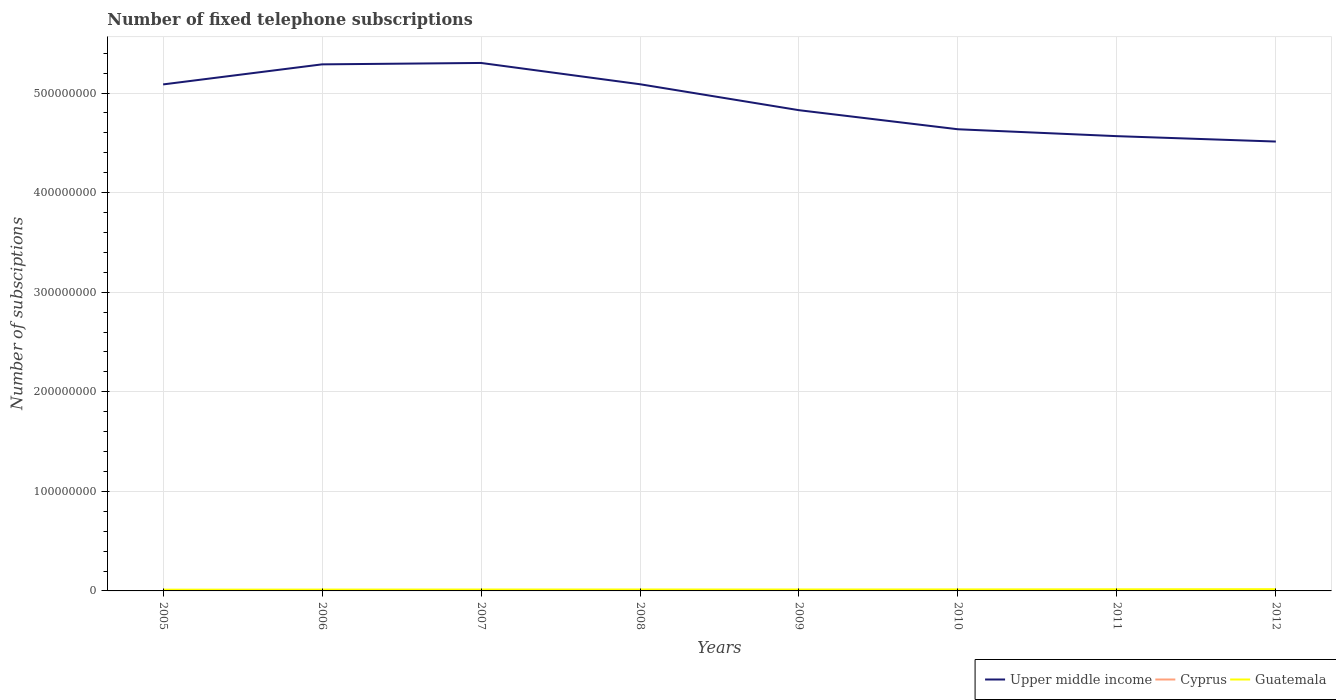Does the line corresponding to Upper middle income intersect with the line corresponding to Cyprus?
Provide a succinct answer. No. Is the number of lines equal to the number of legend labels?
Offer a very short reply. Yes. Across all years, what is the maximum number of fixed telephone subscriptions in Upper middle income?
Offer a terse response. 4.51e+08. What is the total number of fixed telephone subscriptions in Upper middle income in the graph?
Your response must be concise. 1.92e+07. What is the difference between the highest and the second highest number of fixed telephone subscriptions in Upper middle income?
Offer a very short reply. 7.89e+07. What is the difference between the highest and the lowest number of fixed telephone subscriptions in Upper middle income?
Provide a short and direct response. 4. How many lines are there?
Your answer should be very brief. 3. What is the difference between two consecutive major ticks on the Y-axis?
Your response must be concise. 1.00e+08. Are the values on the major ticks of Y-axis written in scientific E-notation?
Provide a succinct answer. No. Does the graph contain grids?
Offer a very short reply. Yes. What is the title of the graph?
Offer a very short reply. Number of fixed telephone subscriptions. Does "Cabo Verde" appear as one of the legend labels in the graph?
Ensure brevity in your answer.  No. What is the label or title of the X-axis?
Your response must be concise. Years. What is the label or title of the Y-axis?
Provide a short and direct response. Number of subsciptions. What is the Number of subsciptions in Upper middle income in 2005?
Ensure brevity in your answer.  5.09e+08. What is the Number of subsciptions of Cyprus in 2005?
Offer a very short reply. 4.20e+05. What is the Number of subsciptions in Guatemala in 2005?
Your answer should be very brief. 1.25e+06. What is the Number of subsciptions in Upper middle income in 2006?
Your response must be concise. 5.29e+08. What is the Number of subsciptions of Cyprus in 2006?
Keep it short and to the point. 4.08e+05. What is the Number of subsciptions of Guatemala in 2006?
Keep it short and to the point. 1.35e+06. What is the Number of subsciptions of Upper middle income in 2007?
Your answer should be compact. 5.30e+08. What is the Number of subsciptions of Cyprus in 2007?
Your answer should be compact. 4.09e+05. What is the Number of subsciptions in Guatemala in 2007?
Your answer should be very brief. 1.41e+06. What is the Number of subsciptions of Upper middle income in 2008?
Your answer should be very brief. 5.09e+08. What is the Number of subsciptions in Cyprus in 2008?
Make the answer very short. 4.13e+05. What is the Number of subsciptions in Guatemala in 2008?
Give a very brief answer. 1.45e+06. What is the Number of subsciptions in Upper middle income in 2009?
Make the answer very short. 4.83e+08. What is the Number of subsciptions of Cyprus in 2009?
Your response must be concise. 4.15e+05. What is the Number of subsciptions of Guatemala in 2009?
Your response must be concise. 1.41e+06. What is the Number of subsciptions in Upper middle income in 2010?
Your answer should be very brief. 4.64e+08. What is the Number of subsciptions of Cyprus in 2010?
Your answer should be very brief. 4.13e+05. What is the Number of subsciptions of Guatemala in 2010?
Make the answer very short. 1.50e+06. What is the Number of subsciptions of Upper middle income in 2011?
Offer a terse response. 4.57e+08. What is the Number of subsciptions in Cyprus in 2011?
Offer a very short reply. 4.05e+05. What is the Number of subsciptions in Guatemala in 2011?
Ensure brevity in your answer.  1.63e+06. What is the Number of subsciptions of Upper middle income in 2012?
Offer a terse response. 4.51e+08. What is the Number of subsciptions in Cyprus in 2012?
Keep it short and to the point. 3.73e+05. What is the Number of subsciptions of Guatemala in 2012?
Your answer should be compact. 1.74e+06. Across all years, what is the maximum Number of subsciptions of Upper middle income?
Provide a short and direct response. 5.30e+08. Across all years, what is the maximum Number of subsciptions of Cyprus?
Offer a very short reply. 4.20e+05. Across all years, what is the maximum Number of subsciptions of Guatemala?
Provide a short and direct response. 1.74e+06. Across all years, what is the minimum Number of subsciptions of Upper middle income?
Keep it short and to the point. 4.51e+08. Across all years, what is the minimum Number of subsciptions in Cyprus?
Offer a very short reply. 3.73e+05. Across all years, what is the minimum Number of subsciptions of Guatemala?
Keep it short and to the point. 1.25e+06. What is the total Number of subsciptions in Upper middle income in the graph?
Your answer should be compact. 3.93e+09. What is the total Number of subsciptions in Cyprus in the graph?
Make the answer very short. 3.26e+06. What is the total Number of subsciptions of Guatemala in the graph?
Offer a very short reply. 1.17e+07. What is the difference between the Number of subsciptions in Upper middle income in 2005 and that in 2006?
Offer a terse response. -2.01e+07. What is the difference between the Number of subsciptions of Cyprus in 2005 and that in 2006?
Give a very brief answer. 1.17e+04. What is the difference between the Number of subsciptions in Guatemala in 2005 and that in 2006?
Your response must be concise. -1.07e+05. What is the difference between the Number of subsciptions in Upper middle income in 2005 and that in 2007?
Keep it short and to the point. -2.15e+07. What is the difference between the Number of subsciptions in Cyprus in 2005 and that in 2007?
Offer a terse response. 1.08e+04. What is the difference between the Number of subsciptions in Guatemala in 2005 and that in 2007?
Your answer should be very brief. -1.66e+05. What is the difference between the Number of subsciptions in Upper middle income in 2005 and that in 2008?
Provide a short and direct response. -1.67e+05. What is the difference between the Number of subsciptions in Cyprus in 2005 and that in 2008?
Your answer should be compact. 6707. What is the difference between the Number of subsciptions in Guatemala in 2005 and that in 2008?
Your answer should be compact. -2.01e+05. What is the difference between the Number of subsciptions of Upper middle income in 2005 and that in 2009?
Keep it short and to the point. 2.59e+07. What is the difference between the Number of subsciptions in Cyprus in 2005 and that in 2009?
Your response must be concise. 5518. What is the difference between the Number of subsciptions in Guatemala in 2005 and that in 2009?
Your answer should be compact. -1.65e+05. What is the difference between the Number of subsciptions of Upper middle income in 2005 and that in 2010?
Ensure brevity in your answer.  4.50e+07. What is the difference between the Number of subsciptions of Cyprus in 2005 and that in 2010?
Your answer should be very brief. 6838. What is the difference between the Number of subsciptions in Guatemala in 2005 and that in 2010?
Make the answer very short. -2.50e+05. What is the difference between the Number of subsciptions in Upper middle income in 2005 and that in 2011?
Your answer should be compact. 5.20e+07. What is the difference between the Number of subsciptions of Cyprus in 2005 and that in 2011?
Make the answer very short. 1.50e+04. What is the difference between the Number of subsciptions of Guatemala in 2005 and that in 2011?
Make the answer very short. -3.78e+05. What is the difference between the Number of subsciptions of Upper middle income in 2005 and that in 2012?
Provide a succinct answer. 5.74e+07. What is the difference between the Number of subsciptions in Cyprus in 2005 and that in 2012?
Provide a short and direct response. 4.68e+04. What is the difference between the Number of subsciptions in Guatemala in 2005 and that in 2012?
Your response must be concise. -4.96e+05. What is the difference between the Number of subsciptions in Upper middle income in 2006 and that in 2007?
Provide a short and direct response. -1.41e+06. What is the difference between the Number of subsciptions of Cyprus in 2006 and that in 2007?
Provide a succinct answer. -960. What is the difference between the Number of subsciptions in Guatemala in 2006 and that in 2007?
Provide a succinct answer. -5.88e+04. What is the difference between the Number of subsciptions of Upper middle income in 2006 and that in 2008?
Offer a terse response. 2.00e+07. What is the difference between the Number of subsciptions in Cyprus in 2006 and that in 2008?
Provide a short and direct response. -5004. What is the difference between the Number of subsciptions in Guatemala in 2006 and that in 2008?
Your answer should be compact. -9.40e+04. What is the difference between the Number of subsciptions in Upper middle income in 2006 and that in 2009?
Offer a terse response. 4.60e+07. What is the difference between the Number of subsciptions of Cyprus in 2006 and that in 2009?
Ensure brevity in your answer.  -6193. What is the difference between the Number of subsciptions in Guatemala in 2006 and that in 2009?
Offer a terse response. -5.83e+04. What is the difference between the Number of subsciptions of Upper middle income in 2006 and that in 2010?
Your answer should be very brief. 6.52e+07. What is the difference between the Number of subsciptions in Cyprus in 2006 and that in 2010?
Give a very brief answer. -4873. What is the difference between the Number of subsciptions in Guatemala in 2006 and that in 2010?
Provide a succinct answer. -1.44e+05. What is the difference between the Number of subsciptions in Upper middle income in 2006 and that in 2011?
Provide a succinct answer. 7.21e+07. What is the difference between the Number of subsciptions in Cyprus in 2006 and that in 2011?
Ensure brevity in your answer.  3295. What is the difference between the Number of subsciptions in Guatemala in 2006 and that in 2011?
Provide a short and direct response. -2.71e+05. What is the difference between the Number of subsciptions in Upper middle income in 2006 and that in 2012?
Make the answer very short. 7.75e+07. What is the difference between the Number of subsciptions of Cyprus in 2006 and that in 2012?
Your answer should be very brief. 3.51e+04. What is the difference between the Number of subsciptions in Guatemala in 2006 and that in 2012?
Your answer should be compact. -3.89e+05. What is the difference between the Number of subsciptions of Upper middle income in 2007 and that in 2008?
Your answer should be compact. 2.14e+07. What is the difference between the Number of subsciptions in Cyprus in 2007 and that in 2008?
Give a very brief answer. -4044. What is the difference between the Number of subsciptions in Guatemala in 2007 and that in 2008?
Keep it short and to the point. -3.52e+04. What is the difference between the Number of subsciptions in Upper middle income in 2007 and that in 2009?
Provide a succinct answer. 4.74e+07. What is the difference between the Number of subsciptions in Cyprus in 2007 and that in 2009?
Offer a very short reply. -5233. What is the difference between the Number of subsciptions of Guatemala in 2007 and that in 2009?
Your answer should be very brief. 461. What is the difference between the Number of subsciptions of Upper middle income in 2007 and that in 2010?
Give a very brief answer. 6.66e+07. What is the difference between the Number of subsciptions in Cyprus in 2007 and that in 2010?
Your response must be concise. -3913. What is the difference between the Number of subsciptions in Guatemala in 2007 and that in 2010?
Provide a succinct answer. -8.49e+04. What is the difference between the Number of subsciptions of Upper middle income in 2007 and that in 2011?
Offer a very short reply. 7.35e+07. What is the difference between the Number of subsciptions of Cyprus in 2007 and that in 2011?
Your answer should be very brief. 4255. What is the difference between the Number of subsciptions of Guatemala in 2007 and that in 2011?
Make the answer very short. -2.13e+05. What is the difference between the Number of subsciptions in Upper middle income in 2007 and that in 2012?
Offer a very short reply. 7.89e+07. What is the difference between the Number of subsciptions in Cyprus in 2007 and that in 2012?
Offer a very short reply. 3.61e+04. What is the difference between the Number of subsciptions in Guatemala in 2007 and that in 2012?
Provide a short and direct response. -3.30e+05. What is the difference between the Number of subsciptions of Upper middle income in 2008 and that in 2009?
Provide a short and direct response. 2.61e+07. What is the difference between the Number of subsciptions in Cyprus in 2008 and that in 2009?
Your answer should be compact. -1189. What is the difference between the Number of subsciptions in Guatemala in 2008 and that in 2009?
Provide a succinct answer. 3.57e+04. What is the difference between the Number of subsciptions in Upper middle income in 2008 and that in 2010?
Your response must be concise. 4.52e+07. What is the difference between the Number of subsciptions of Cyprus in 2008 and that in 2010?
Provide a short and direct response. 131. What is the difference between the Number of subsciptions in Guatemala in 2008 and that in 2010?
Provide a short and direct response. -4.97e+04. What is the difference between the Number of subsciptions of Upper middle income in 2008 and that in 2011?
Ensure brevity in your answer.  5.21e+07. What is the difference between the Number of subsciptions in Cyprus in 2008 and that in 2011?
Give a very brief answer. 8299. What is the difference between the Number of subsciptions in Guatemala in 2008 and that in 2011?
Your answer should be compact. -1.77e+05. What is the difference between the Number of subsciptions of Upper middle income in 2008 and that in 2012?
Your answer should be compact. 5.75e+07. What is the difference between the Number of subsciptions in Cyprus in 2008 and that in 2012?
Offer a very short reply. 4.01e+04. What is the difference between the Number of subsciptions of Guatemala in 2008 and that in 2012?
Provide a short and direct response. -2.95e+05. What is the difference between the Number of subsciptions of Upper middle income in 2009 and that in 2010?
Your response must be concise. 1.92e+07. What is the difference between the Number of subsciptions in Cyprus in 2009 and that in 2010?
Your answer should be very brief. 1320. What is the difference between the Number of subsciptions of Guatemala in 2009 and that in 2010?
Make the answer very short. -8.54e+04. What is the difference between the Number of subsciptions in Upper middle income in 2009 and that in 2011?
Keep it short and to the point. 2.61e+07. What is the difference between the Number of subsciptions of Cyprus in 2009 and that in 2011?
Offer a very short reply. 9488. What is the difference between the Number of subsciptions in Guatemala in 2009 and that in 2011?
Provide a succinct answer. -2.13e+05. What is the difference between the Number of subsciptions of Upper middle income in 2009 and that in 2012?
Keep it short and to the point. 3.15e+07. What is the difference between the Number of subsciptions of Cyprus in 2009 and that in 2012?
Your response must be concise. 4.13e+04. What is the difference between the Number of subsciptions in Guatemala in 2009 and that in 2012?
Offer a very short reply. -3.31e+05. What is the difference between the Number of subsciptions of Upper middle income in 2010 and that in 2011?
Provide a short and direct response. 6.92e+06. What is the difference between the Number of subsciptions of Cyprus in 2010 and that in 2011?
Your response must be concise. 8168. What is the difference between the Number of subsciptions in Guatemala in 2010 and that in 2011?
Keep it short and to the point. -1.28e+05. What is the difference between the Number of subsciptions in Upper middle income in 2010 and that in 2012?
Your answer should be compact. 1.23e+07. What is the difference between the Number of subsciptions of Cyprus in 2010 and that in 2012?
Offer a very short reply. 4.00e+04. What is the difference between the Number of subsciptions of Guatemala in 2010 and that in 2012?
Provide a short and direct response. -2.45e+05. What is the difference between the Number of subsciptions in Upper middle income in 2011 and that in 2012?
Offer a terse response. 5.41e+06. What is the difference between the Number of subsciptions of Cyprus in 2011 and that in 2012?
Your response must be concise. 3.18e+04. What is the difference between the Number of subsciptions of Guatemala in 2011 and that in 2012?
Your response must be concise. -1.18e+05. What is the difference between the Number of subsciptions in Upper middle income in 2005 and the Number of subsciptions in Cyprus in 2006?
Your answer should be very brief. 5.08e+08. What is the difference between the Number of subsciptions in Upper middle income in 2005 and the Number of subsciptions in Guatemala in 2006?
Your answer should be very brief. 5.07e+08. What is the difference between the Number of subsciptions in Cyprus in 2005 and the Number of subsciptions in Guatemala in 2006?
Your answer should be very brief. -9.35e+05. What is the difference between the Number of subsciptions of Upper middle income in 2005 and the Number of subsciptions of Cyprus in 2007?
Keep it short and to the point. 5.08e+08. What is the difference between the Number of subsciptions in Upper middle income in 2005 and the Number of subsciptions in Guatemala in 2007?
Your response must be concise. 5.07e+08. What is the difference between the Number of subsciptions of Cyprus in 2005 and the Number of subsciptions of Guatemala in 2007?
Provide a short and direct response. -9.94e+05. What is the difference between the Number of subsciptions of Upper middle income in 2005 and the Number of subsciptions of Cyprus in 2008?
Your answer should be very brief. 5.08e+08. What is the difference between the Number of subsciptions of Upper middle income in 2005 and the Number of subsciptions of Guatemala in 2008?
Your answer should be very brief. 5.07e+08. What is the difference between the Number of subsciptions of Cyprus in 2005 and the Number of subsciptions of Guatemala in 2008?
Ensure brevity in your answer.  -1.03e+06. What is the difference between the Number of subsciptions of Upper middle income in 2005 and the Number of subsciptions of Cyprus in 2009?
Provide a short and direct response. 5.08e+08. What is the difference between the Number of subsciptions in Upper middle income in 2005 and the Number of subsciptions in Guatemala in 2009?
Your answer should be very brief. 5.07e+08. What is the difference between the Number of subsciptions in Cyprus in 2005 and the Number of subsciptions in Guatemala in 2009?
Provide a succinct answer. -9.93e+05. What is the difference between the Number of subsciptions of Upper middle income in 2005 and the Number of subsciptions of Cyprus in 2010?
Your answer should be compact. 5.08e+08. What is the difference between the Number of subsciptions in Upper middle income in 2005 and the Number of subsciptions in Guatemala in 2010?
Give a very brief answer. 5.07e+08. What is the difference between the Number of subsciptions of Cyprus in 2005 and the Number of subsciptions of Guatemala in 2010?
Ensure brevity in your answer.  -1.08e+06. What is the difference between the Number of subsciptions in Upper middle income in 2005 and the Number of subsciptions in Cyprus in 2011?
Provide a succinct answer. 5.08e+08. What is the difference between the Number of subsciptions of Upper middle income in 2005 and the Number of subsciptions of Guatemala in 2011?
Offer a terse response. 5.07e+08. What is the difference between the Number of subsciptions in Cyprus in 2005 and the Number of subsciptions in Guatemala in 2011?
Your response must be concise. -1.21e+06. What is the difference between the Number of subsciptions in Upper middle income in 2005 and the Number of subsciptions in Cyprus in 2012?
Make the answer very short. 5.08e+08. What is the difference between the Number of subsciptions in Upper middle income in 2005 and the Number of subsciptions in Guatemala in 2012?
Your answer should be very brief. 5.07e+08. What is the difference between the Number of subsciptions in Cyprus in 2005 and the Number of subsciptions in Guatemala in 2012?
Your answer should be compact. -1.32e+06. What is the difference between the Number of subsciptions in Upper middle income in 2006 and the Number of subsciptions in Cyprus in 2007?
Make the answer very short. 5.28e+08. What is the difference between the Number of subsciptions in Upper middle income in 2006 and the Number of subsciptions in Guatemala in 2007?
Offer a terse response. 5.27e+08. What is the difference between the Number of subsciptions in Cyprus in 2006 and the Number of subsciptions in Guatemala in 2007?
Provide a succinct answer. -1.01e+06. What is the difference between the Number of subsciptions of Upper middle income in 2006 and the Number of subsciptions of Cyprus in 2008?
Keep it short and to the point. 5.28e+08. What is the difference between the Number of subsciptions in Upper middle income in 2006 and the Number of subsciptions in Guatemala in 2008?
Your answer should be very brief. 5.27e+08. What is the difference between the Number of subsciptions of Cyprus in 2006 and the Number of subsciptions of Guatemala in 2008?
Offer a very short reply. -1.04e+06. What is the difference between the Number of subsciptions in Upper middle income in 2006 and the Number of subsciptions in Cyprus in 2009?
Offer a terse response. 5.28e+08. What is the difference between the Number of subsciptions in Upper middle income in 2006 and the Number of subsciptions in Guatemala in 2009?
Ensure brevity in your answer.  5.27e+08. What is the difference between the Number of subsciptions in Cyprus in 2006 and the Number of subsciptions in Guatemala in 2009?
Your answer should be very brief. -1.00e+06. What is the difference between the Number of subsciptions of Upper middle income in 2006 and the Number of subsciptions of Cyprus in 2010?
Provide a short and direct response. 5.28e+08. What is the difference between the Number of subsciptions of Upper middle income in 2006 and the Number of subsciptions of Guatemala in 2010?
Make the answer very short. 5.27e+08. What is the difference between the Number of subsciptions of Cyprus in 2006 and the Number of subsciptions of Guatemala in 2010?
Your answer should be compact. -1.09e+06. What is the difference between the Number of subsciptions of Upper middle income in 2006 and the Number of subsciptions of Cyprus in 2011?
Make the answer very short. 5.28e+08. What is the difference between the Number of subsciptions in Upper middle income in 2006 and the Number of subsciptions in Guatemala in 2011?
Give a very brief answer. 5.27e+08. What is the difference between the Number of subsciptions of Cyprus in 2006 and the Number of subsciptions of Guatemala in 2011?
Make the answer very short. -1.22e+06. What is the difference between the Number of subsciptions in Upper middle income in 2006 and the Number of subsciptions in Cyprus in 2012?
Your answer should be compact. 5.28e+08. What is the difference between the Number of subsciptions of Upper middle income in 2006 and the Number of subsciptions of Guatemala in 2012?
Offer a terse response. 5.27e+08. What is the difference between the Number of subsciptions in Cyprus in 2006 and the Number of subsciptions in Guatemala in 2012?
Your response must be concise. -1.34e+06. What is the difference between the Number of subsciptions of Upper middle income in 2007 and the Number of subsciptions of Cyprus in 2008?
Your answer should be compact. 5.30e+08. What is the difference between the Number of subsciptions of Upper middle income in 2007 and the Number of subsciptions of Guatemala in 2008?
Provide a short and direct response. 5.29e+08. What is the difference between the Number of subsciptions in Cyprus in 2007 and the Number of subsciptions in Guatemala in 2008?
Your answer should be very brief. -1.04e+06. What is the difference between the Number of subsciptions of Upper middle income in 2007 and the Number of subsciptions of Cyprus in 2009?
Your answer should be compact. 5.30e+08. What is the difference between the Number of subsciptions in Upper middle income in 2007 and the Number of subsciptions in Guatemala in 2009?
Provide a succinct answer. 5.29e+08. What is the difference between the Number of subsciptions in Cyprus in 2007 and the Number of subsciptions in Guatemala in 2009?
Your response must be concise. -1.00e+06. What is the difference between the Number of subsciptions of Upper middle income in 2007 and the Number of subsciptions of Cyprus in 2010?
Give a very brief answer. 5.30e+08. What is the difference between the Number of subsciptions in Upper middle income in 2007 and the Number of subsciptions in Guatemala in 2010?
Provide a succinct answer. 5.29e+08. What is the difference between the Number of subsciptions of Cyprus in 2007 and the Number of subsciptions of Guatemala in 2010?
Offer a very short reply. -1.09e+06. What is the difference between the Number of subsciptions of Upper middle income in 2007 and the Number of subsciptions of Cyprus in 2011?
Provide a short and direct response. 5.30e+08. What is the difference between the Number of subsciptions in Upper middle income in 2007 and the Number of subsciptions in Guatemala in 2011?
Your answer should be compact. 5.29e+08. What is the difference between the Number of subsciptions in Cyprus in 2007 and the Number of subsciptions in Guatemala in 2011?
Keep it short and to the point. -1.22e+06. What is the difference between the Number of subsciptions of Upper middle income in 2007 and the Number of subsciptions of Cyprus in 2012?
Your answer should be compact. 5.30e+08. What is the difference between the Number of subsciptions of Upper middle income in 2007 and the Number of subsciptions of Guatemala in 2012?
Your answer should be compact. 5.28e+08. What is the difference between the Number of subsciptions of Cyprus in 2007 and the Number of subsciptions of Guatemala in 2012?
Ensure brevity in your answer.  -1.33e+06. What is the difference between the Number of subsciptions in Upper middle income in 2008 and the Number of subsciptions in Cyprus in 2009?
Keep it short and to the point. 5.08e+08. What is the difference between the Number of subsciptions of Upper middle income in 2008 and the Number of subsciptions of Guatemala in 2009?
Your answer should be very brief. 5.07e+08. What is the difference between the Number of subsciptions of Cyprus in 2008 and the Number of subsciptions of Guatemala in 2009?
Keep it short and to the point. -1.00e+06. What is the difference between the Number of subsciptions in Upper middle income in 2008 and the Number of subsciptions in Cyprus in 2010?
Ensure brevity in your answer.  5.08e+08. What is the difference between the Number of subsciptions in Upper middle income in 2008 and the Number of subsciptions in Guatemala in 2010?
Your answer should be compact. 5.07e+08. What is the difference between the Number of subsciptions in Cyprus in 2008 and the Number of subsciptions in Guatemala in 2010?
Keep it short and to the point. -1.09e+06. What is the difference between the Number of subsciptions in Upper middle income in 2008 and the Number of subsciptions in Cyprus in 2011?
Provide a short and direct response. 5.08e+08. What is the difference between the Number of subsciptions in Upper middle income in 2008 and the Number of subsciptions in Guatemala in 2011?
Offer a terse response. 5.07e+08. What is the difference between the Number of subsciptions of Cyprus in 2008 and the Number of subsciptions of Guatemala in 2011?
Keep it short and to the point. -1.21e+06. What is the difference between the Number of subsciptions of Upper middle income in 2008 and the Number of subsciptions of Cyprus in 2012?
Provide a short and direct response. 5.08e+08. What is the difference between the Number of subsciptions in Upper middle income in 2008 and the Number of subsciptions in Guatemala in 2012?
Keep it short and to the point. 5.07e+08. What is the difference between the Number of subsciptions of Cyprus in 2008 and the Number of subsciptions of Guatemala in 2012?
Offer a very short reply. -1.33e+06. What is the difference between the Number of subsciptions of Upper middle income in 2009 and the Number of subsciptions of Cyprus in 2010?
Provide a succinct answer. 4.82e+08. What is the difference between the Number of subsciptions of Upper middle income in 2009 and the Number of subsciptions of Guatemala in 2010?
Provide a short and direct response. 4.81e+08. What is the difference between the Number of subsciptions in Cyprus in 2009 and the Number of subsciptions in Guatemala in 2010?
Your answer should be compact. -1.08e+06. What is the difference between the Number of subsciptions of Upper middle income in 2009 and the Number of subsciptions of Cyprus in 2011?
Provide a short and direct response. 4.82e+08. What is the difference between the Number of subsciptions of Upper middle income in 2009 and the Number of subsciptions of Guatemala in 2011?
Keep it short and to the point. 4.81e+08. What is the difference between the Number of subsciptions in Cyprus in 2009 and the Number of subsciptions in Guatemala in 2011?
Make the answer very short. -1.21e+06. What is the difference between the Number of subsciptions in Upper middle income in 2009 and the Number of subsciptions in Cyprus in 2012?
Keep it short and to the point. 4.82e+08. What is the difference between the Number of subsciptions in Upper middle income in 2009 and the Number of subsciptions in Guatemala in 2012?
Your answer should be compact. 4.81e+08. What is the difference between the Number of subsciptions in Cyprus in 2009 and the Number of subsciptions in Guatemala in 2012?
Your response must be concise. -1.33e+06. What is the difference between the Number of subsciptions of Upper middle income in 2010 and the Number of subsciptions of Cyprus in 2011?
Your answer should be compact. 4.63e+08. What is the difference between the Number of subsciptions in Upper middle income in 2010 and the Number of subsciptions in Guatemala in 2011?
Your answer should be very brief. 4.62e+08. What is the difference between the Number of subsciptions in Cyprus in 2010 and the Number of subsciptions in Guatemala in 2011?
Keep it short and to the point. -1.21e+06. What is the difference between the Number of subsciptions in Upper middle income in 2010 and the Number of subsciptions in Cyprus in 2012?
Offer a very short reply. 4.63e+08. What is the difference between the Number of subsciptions of Upper middle income in 2010 and the Number of subsciptions of Guatemala in 2012?
Your answer should be compact. 4.62e+08. What is the difference between the Number of subsciptions in Cyprus in 2010 and the Number of subsciptions in Guatemala in 2012?
Offer a very short reply. -1.33e+06. What is the difference between the Number of subsciptions in Upper middle income in 2011 and the Number of subsciptions in Cyprus in 2012?
Provide a short and direct response. 4.56e+08. What is the difference between the Number of subsciptions of Upper middle income in 2011 and the Number of subsciptions of Guatemala in 2012?
Your answer should be very brief. 4.55e+08. What is the difference between the Number of subsciptions of Cyprus in 2011 and the Number of subsciptions of Guatemala in 2012?
Offer a very short reply. -1.34e+06. What is the average Number of subsciptions of Upper middle income per year?
Offer a very short reply. 4.91e+08. What is the average Number of subsciptions of Cyprus per year?
Your answer should be very brief. 4.07e+05. What is the average Number of subsciptions of Guatemala per year?
Provide a succinct answer. 1.47e+06. In the year 2005, what is the difference between the Number of subsciptions of Upper middle income and Number of subsciptions of Cyprus?
Provide a succinct answer. 5.08e+08. In the year 2005, what is the difference between the Number of subsciptions in Upper middle income and Number of subsciptions in Guatemala?
Your answer should be very brief. 5.07e+08. In the year 2005, what is the difference between the Number of subsciptions of Cyprus and Number of subsciptions of Guatemala?
Offer a very short reply. -8.28e+05. In the year 2006, what is the difference between the Number of subsciptions in Upper middle income and Number of subsciptions in Cyprus?
Keep it short and to the point. 5.28e+08. In the year 2006, what is the difference between the Number of subsciptions in Upper middle income and Number of subsciptions in Guatemala?
Your answer should be compact. 5.27e+08. In the year 2006, what is the difference between the Number of subsciptions in Cyprus and Number of subsciptions in Guatemala?
Offer a terse response. -9.47e+05. In the year 2007, what is the difference between the Number of subsciptions in Upper middle income and Number of subsciptions in Cyprus?
Offer a terse response. 5.30e+08. In the year 2007, what is the difference between the Number of subsciptions in Upper middle income and Number of subsciptions in Guatemala?
Offer a terse response. 5.29e+08. In the year 2007, what is the difference between the Number of subsciptions of Cyprus and Number of subsciptions of Guatemala?
Your response must be concise. -1.00e+06. In the year 2008, what is the difference between the Number of subsciptions in Upper middle income and Number of subsciptions in Cyprus?
Ensure brevity in your answer.  5.08e+08. In the year 2008, what is the difference between the Number of subsciptions of Upper middle income and Number of subsciptions of Guatemala?
Keep it short and to the point. 5.07e+08. In the year 2008, what is the difference between the Number of subsciptions of Cyprus and Number of subsciptions of Guatemala?
Give a very brief answer. -1.04e+06. In the year 2009, what is the difference between the Number of subsciptions in Upper middle income and Number of subsciptions in Cyprus?
Provide a short and direct response. 4.82e+08. In the year 2009, what is the difference between the Number of subsciptions of Upper middle income and Number of subsciptions of Guatemala?
Offer a terse response. 4.81e+08. In the year 2009, what is the difference between the Number of subsciptions of Cyprus and Number of subsciptions of Guatemala?
Your response must be concise. -9.99e+05. In the year 2010, what is the difference between the Number of subsciptions of Upper middle income and Number of subsciptions of Cyprus?
Keep it short and to the point. 4.63e+08. In the year 2010, what is the difference between the Number of subsciptions in Upper middle income and Number of subsciptions in Guatemala?
Your answer should be compact. 4.62e+08. In the year 2010, what is the difference between the Number of subsciptions of Cyprus and Number of subsciptions of Guatemala?
Keep it short and to the point. -1.09e+06. In the year 2011, what is the difference between the Number of subsciptions in Upper middle income and Number of subsciptions in Cyprus?
Keep it short and to the point. 4.56e+08. In the year 2011, what is the difference between the Number of subsciptions of Upper middle income and Number of subsciptions of Guatemala?
Your response must be concise. 4.55e+08. In the year 2011, what is the difference between the Number of subsciptions of Cyprus and Number of subsciptions of Guatemala?
Ensure brevity in your answer.  -1.22e+06. In the year 2012, what is the difference between the Number of subsciptions of Upper middle income and Number of subsciptions of Cyprus?
Keep it short and to the point. 4.51e+08. In the year 2012, what is the difference between the Number of subsciptions of Upper middle income and Number of subsciptions of Guatemala?
Keep it short and to the point. 4.50e+08. In the year 2012, what is the difference between the Number of subsciptions in Cyprus and Number of subsciptions in Guatemala?
Your response must be concise. -1.37e+06. What is the ratio of the Number of subsciptions of Upper middle income in 2005 to that in 2006?
Offer a terse response. 0.96. What is the ratio of the Number of subsciptions in Cyprus in 2005 to that in 2006?
Provide a short and direct response. 1.03. What is the ratio of the Number of subsciptions in Guatemala in 2005 to that in 2006?
Your answer should be very brief. 0.92. What is the ratio of the Number of subsciptions of Upper middle income in 2005 to that in 2007?
Your answer should be very brief. 0.96. What is the ratio of the Number of subsciptions in Cyprus in 2005 to that in 2007?
Offer a very short reply. 1.03. What is the ratio of the Number of subsciptions in Guatemala in 2005 to that in 2007?
Offer a very short reply. 0.88. What is the ratio of the Number of subsciptions of Upper middle income in 2005 to that in 2008?
Provide a succinct answer. 1. What is the ratio of the Number of subsciptions in Cyprus in 2005 to that in 2008?
Offer a terse response. 1.02. What is the ratio of the Number of subsciptions of Guatemala in 2005 to that in 2008?
Your answer should be very brief. 0.86. What is the ratio of the Number of subsciptions of Upper middle income in 2005 to that in 2009?
Your response must be concise. 1.05. What is the ratio of the Number of subsciptions in Cyprus in 2005 to that in 2009?
Your answer should be very brief. 1.01. What is the ratio of the Number of subsciptions of Guatemala in 2005 to that in 2009?
Offer a very short reply. 0.88. What is the ratio of the Number of subsciptions of Upper middle income in 2005 to that in 2010?
Provide a short and direct response. 1.1. What is the ratio of the Number of subsciptions of Cyprus in 2005 to that in 2010?
Keep it short and to the point. 1.02. What is the ratio of the Number of subsciptions of Guatemala in 2005 to that in 2010?
Your response must be concise. 0.83. What is the ratio of the Number of subsciptions of Upper middle income in 2005 to that in 2011?
Your answer should be compact. 1.11. What is the ratio of the Number of subsciptions in Guatemala in 2005 to that in 2011?
Your response must be concise. 0.77. What is the ratio of the Number of subsciptions in Upper middle income in 2005 to that in 2012?
Make the answer very short. 1.13. What is the ratio of the Number of subsciptions in Cyprus in 2005 to that in 2012?
Offer a terse response. 1.13. What is the ratio of the Number of subsciptions in Guatemala in 2005 to that in 2012?
Offer a terse response. 0.72. What is the ratio of the Number of subsciptions in Upper middle income in 2006 to that in 2007?
Provide a short and direct response. 1. What is the ratio of the Number of subsciptions of Guatemala in 2006 to that in 2007?
Keep it short and to the point. 0.96. What is the ratio of the Number of subsciptions of Upper middle income in 2006 to that in 2008?
Give a very brief answer. 1.04. What is the ratio of the Number of subsciptions of Cyprus in 2006 to that in 2008?
Your response must be concise. 0.99. What is the ratio of the Number of subsciptions of Guatemala in 2006 to that in 2008?
Provide a short and direct response. 0.94. What is the ratio of the Number of subsciptions of Upper middle income in 2006 to that in 2009?
Your answer should be compact. 1.1. What is the ratio of the Number of subsciptions of Cyprus in 2006 to that in 2009?
Your answer should be very brief. 0.99. What is the ratio of the Number of subsciptions in Guatemala in 2006 to that in 2009?
Give a very brief answer. 0.96. What is the ratio of the Number of subsciptions in Upper middle income in 2006 to that in 2010?
Your answer should be compact. 1.14. What is the ratio of the Number of subsciptions of Guatemala in 2006 to that in 2010?
Your answer should be compact. 0.9. What is the ratio of the Number of subsciptions in Upper middle income in 2006 to that in 2011?
Your answer should be compact. 1.16. What is the ratio of the Number of subsciptions of Cyprus in 2006 to that in 2011?
Ensure brevity in your answer.  1.01. What is the ratio of the Number of subsciptions of Guatemala in 2006 to that in 2011?
Your answer should be compact. 0.83. What is the ratio of the Number of subsciptions in Upper middle income in 2006 to that in 2012?
Your response must be concise. 1.17. What is the ratio of the Number of subsciptions in Cyprus in 2006 to that in 2012?
Your answer should be compact. 1.09. What is the ratio of the Number of subsciptions of Guatemala in 2006 to that in 2012?
Provide a short and direct response. 0.78. What is the ratio of the Number of subsciptions in Upper middle income in 2007 to that in 2008?
Offer a terse response. 1.04. What is the ratio of the Number of subsciptions of Cyprus in 2007 to that in 2008?
Offer a very short reply. 0.99. What is the ratio of the Number of subsciptions of Guatemala in 2007 to that in 2008?
Ensure brevity in your answer.  0.98. What is the ratio of the Number of subsciptions in Upper middle income in 2007 to that in 2009?
Your response must be concise. 1.1. What is the ratio of the Number of subsciptions of Cyprus in 2007 to that in 2009?
Offer a very short reply. 0.99. What is the ratio of the Number of subsciptions in Upper middle income in 2007 to that in 2010?
Give a very brief answer. 1.14. What is the ratio of the Number of subsciptions of Guatemala in 2007 to that in 2010?
Provide a succinct answer. 0.94. What is the ratio of the Number of subsciptions of Upper middle income in 2007 to that in 2011?
Provide a succinct answer. 1.16. What is the ratio of the Number of subsciptions of Cyprus in 2007 to that in 2011?
Offer a very short reply. 1.01. What is the ratio of the Number of subsciptions in Guatemala in 2007 to that in 2011?
Your answer should be compact. 0.87. What is the ratio of the Number of subsciptions of Upper middle income in 2007 to that in 2012?
Keep it short and to the point. 1.17. What is the ratio of the Number of subsciptions in Cyprus in 2007 to that in 2012?
Provide a succinct answer. 1.1. What is the ratio of the Number of subsciptions in Guatemala in 2007 to that in 2012?
Provide a succinct answer. 0.81. What is the ratio of the Number of subsciptions in Upper middle income in 2008 to that in 2009?
Make the answer very short. 1.05. What is the ratio of the Number of subsciptions of Guatemala in 2008 to that in 2009?
Your answer should be compact. 1.03. What is the ratio of the Number of subsciptions of Upper middle income in 2008 to that in 2010?
Your answer should be very brief. 1.1. What is the ratio of the Number of subsciptions in Cyprus in 2008 to that in 2010?
Keep it short and to the point. 1. What is the ratio of the Number of subsciptions of Guatemala in 2008 to that in 2010?
Offer a very short reply. 0.97. What is the ratio of the Number of subsciptions in Upper middle income in 2008 to that in 2011?
Your response must be concise. 1.11. What is the ratio of the Number of subsciptions of Cyprus in 2008 to that in 2011?
Offer a very short reply. 1.02. What is the ratio of the Number of subsciptions of Guatemala in 2008 to that in 2011?
Ensure brevity in your answer.  0.89. What is the ratio of the Number of subsciptions in Upper middle income in 2008 to that in 2012?
Offer a terse response. 1.13. What is the ratio of the Number of subsciptions in Cyprus in 2008 to that in 2012?
Provide a succinct answer. 1.11. What is the ratio of the Number of subsciptions in Guatemala in 2008 to that in 2012?
Your response must be concise. 0.83. What is the ratio of the Number of subsciptions of Upper middle income in 2009 to that in 2010?
Keep it short and to the point. 1.04. What is the ratio of the Number of subsciptions in Guatemala in 2009 to that in 2010?
Your response must be concise. 0.94. What is the ratio of the Number of subsciptions of Upper middle income in 2009 to that in 2011?
Give a very brief answer. 1.06. What is the ratio of the Number of subsciptions of Cyprus in 2009 to that in 2011?
Your answer should be very brief. 1.02. What is the ratio of the Number of subsciptions of Guatemala in 2009 to that in 2011?
Your response must be concise. 0.87. What is the ratio of the Number of subsciptions in Upper middle income in 2009 to that in 2012?
Ensure brevity in your answer.  1.07. What is the ratio of the Number of subsciptions in Cyprus in 2009 to that in 2012?
Give a very brief answer. 1.11. What is the ratio of the Number of subsciptions of Guatemala in 2009 to that in 2012?
Provide a succinct answer. 0.81. What is the ratio of the Number of subsciptions in Upper middle income in 2010 to that in 2011?
Your answer should be compact. 1.02. What is the ratio of the Number of subsciptions in Cyprus in 2010 to that in 2011?
Provide a succinct answer. 1.02. What is the ratio of the Number of subsciptions of Guatemala in 2010 to that in 2011?
Provide a short and direct response. 0.92. What is the ratio of the Number of subsciptions in Upper middle income in 2010 to that in 2012?
Provide a succinct answer. 1.03. What is the ratio of the Number of subsciptions of Cyprus in 2010 to that in 2012?
Keep it short and to the point. 1.11. What is the ratio of the Number of subsciptions of Guatemala in 2010 to that in 2012?
Offer a terse response. 0.86. What is the ratio of the Number of subsciptions of Cyprus in 2011 to that in 2012?
Provide a succinct answer. 1.09. What is the ratio of the Number of subsciptions in Guatemala in 2011 to that in 2012?
Your response must be concise. 0.93. What is the difference between the highest and the second highest Number of subsciptions of Upper middle income?
Provide a short and direct response. 1.41e+06. What is the difference between the highest and the second highest Number of subsciptions of Cyprus?
Offer a very short reply. 5518. What is the difference between the highest and the second highest Number of subsciptions in Guatemala?
Keep it short and to the point. 1.18e+05. What is the difference between the highest and the lowest Number of subsciptions of Upper middle income?
Offer a terse response. 7.89e+07. What is the difference between the highest and the lowest Number of subsciptions of Cyprus?
Your answer should be very brief. 4.68e+04. What is the difference between the highest and the lowest Number of subsciptions of Guatemala?
Offer a terse response. 4.96e+05. 